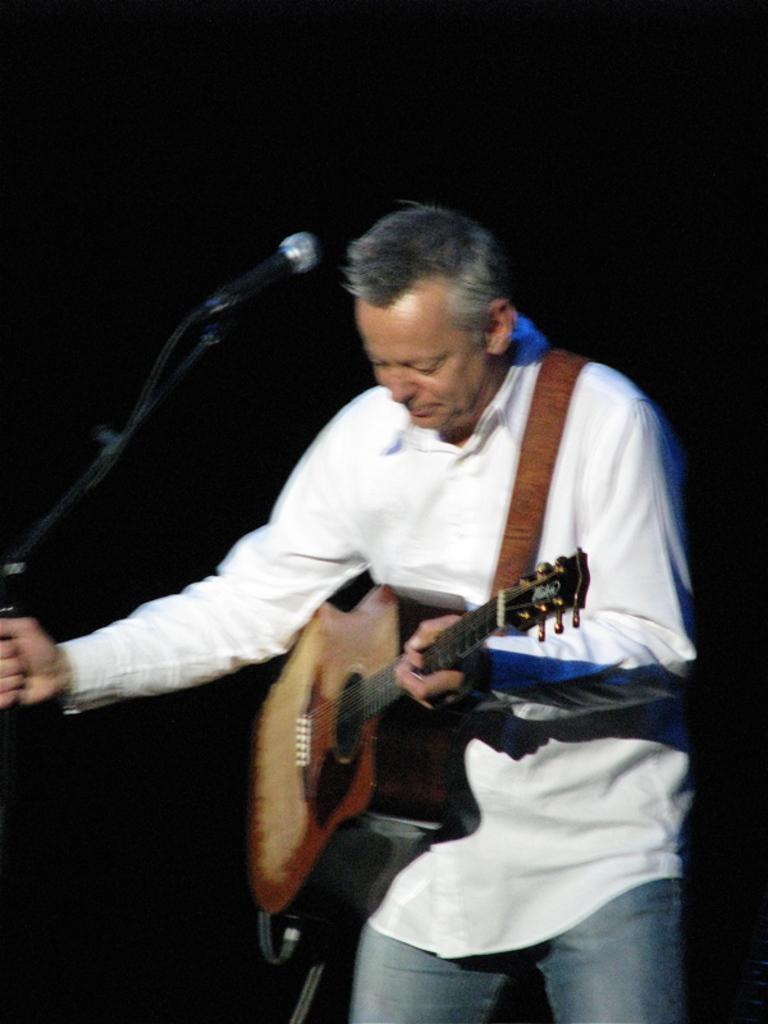How would you summarize this image in a sentence or two? Background is dark. Here we can see a man standing in front of a mike, singing and he is holding a guitar with his hand. He wore white colour shirt and light colour denim blue jeans. 